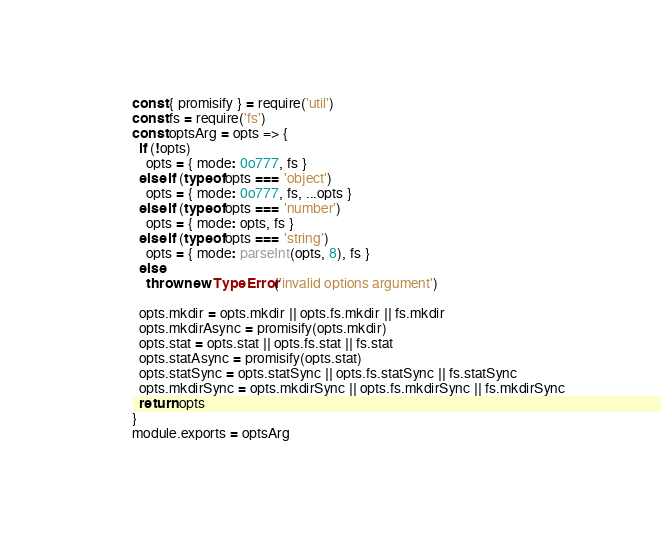Convert code to text. <code><loc_0><loc_0><loc_500><loc_500><_JavaScript_>const { promisify } = require('util')
const fs = require('fs')
const optsArg = opts => {
  if (!opts)
    opts = { mode: 0o777, fs }
  else if (typeof opts === 'object')
    opts = { mode: 0o777, fs, ...opts }
  else if (typeof opts === 'number')
    opts = { mode: opts, fs }
  else if (typeof opts === 'string')
    opts = { mode: parseInt(opts, 8), fs }
  else
    throw new TypeError('invalid options argument')

  opts.mkdir = opts.mkdir || opts.fs.mkdir || fs.mkdir
  opts.mkdirAsync = promisify(opts.mkdir)
  opts.stat = opts.stat || opts.fs.stat || fs.stat
  opts.statAsync = promisify(opts.stat)
  opts.statSync = opts.statSync || opts.fs.statSync || fs.statSync
  opts.mkdirSync = opts.mkdirSync || opts.fs.mkdirSync || fs.mkdirSync
  return opts
}
module.exports = optsArg
</code> 